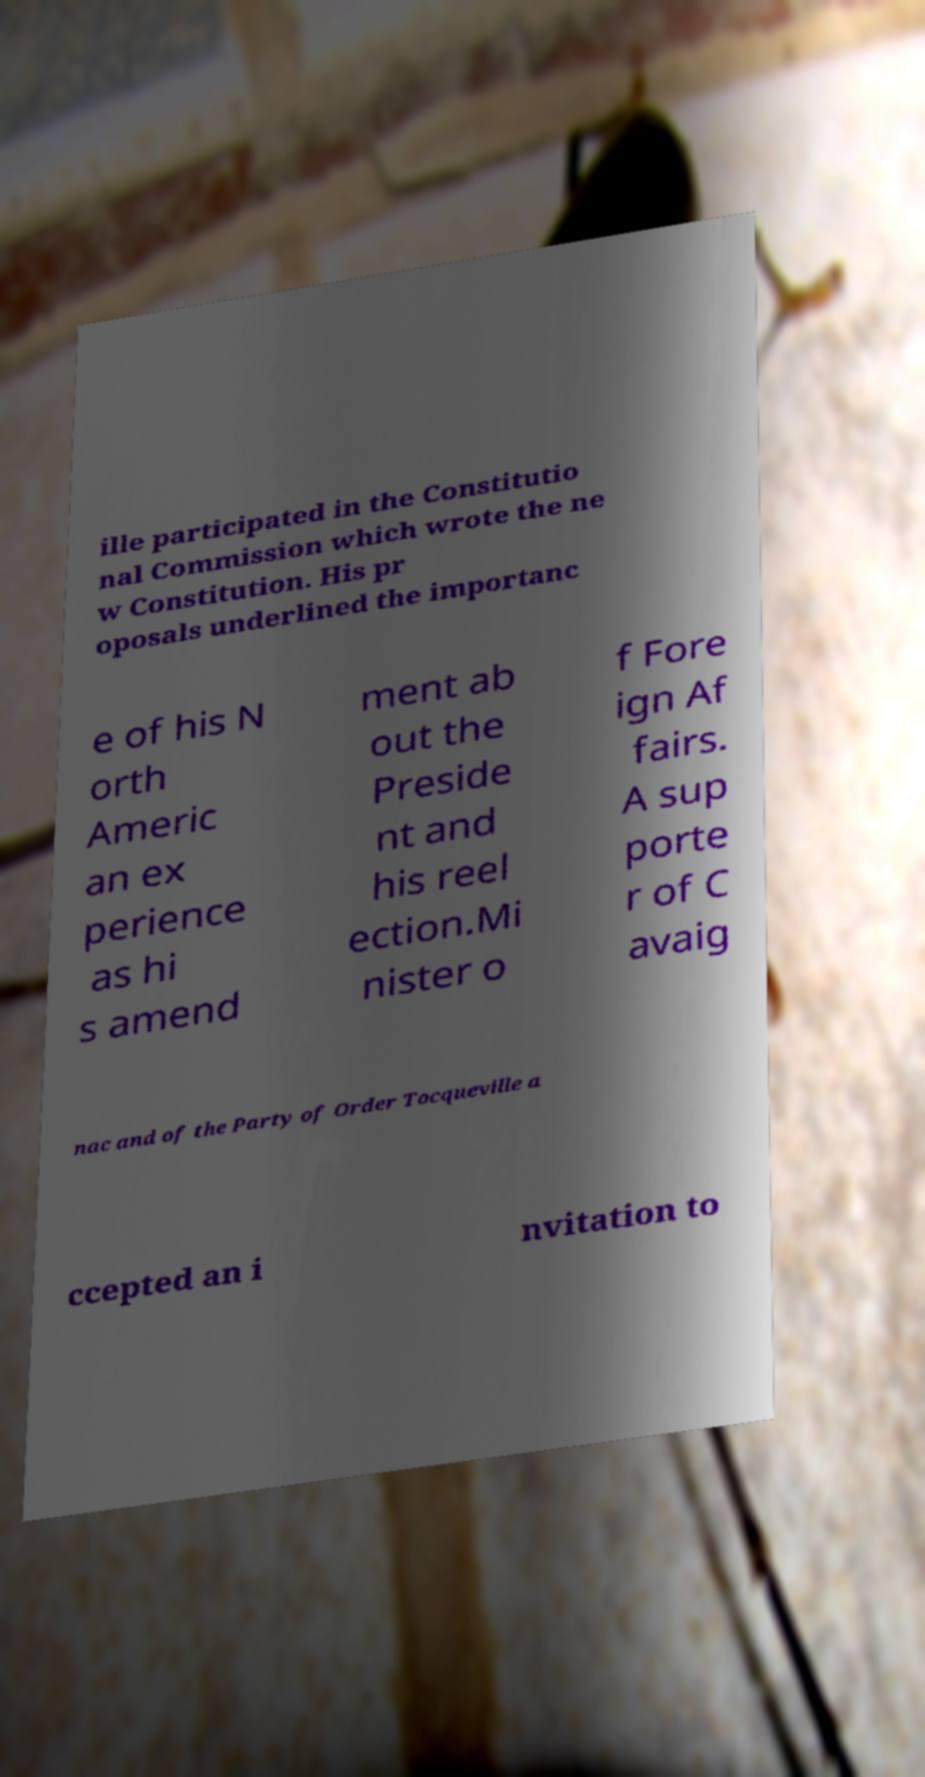Can you accurately transcribe the text from the provided image for me? ille participated in the Constitutio nal Commission which wrote the ne w Constitution. His pr oposals underlined the importanc e of his N orth Americ an ex perience as hi s amend ment ab out the Preside nt and his reel ection.Mi nister o f Fore ign Af fairs. A sup porte r of C avaig nac and of the Party of Order Tocqueville a ccepted an i nvitation to 